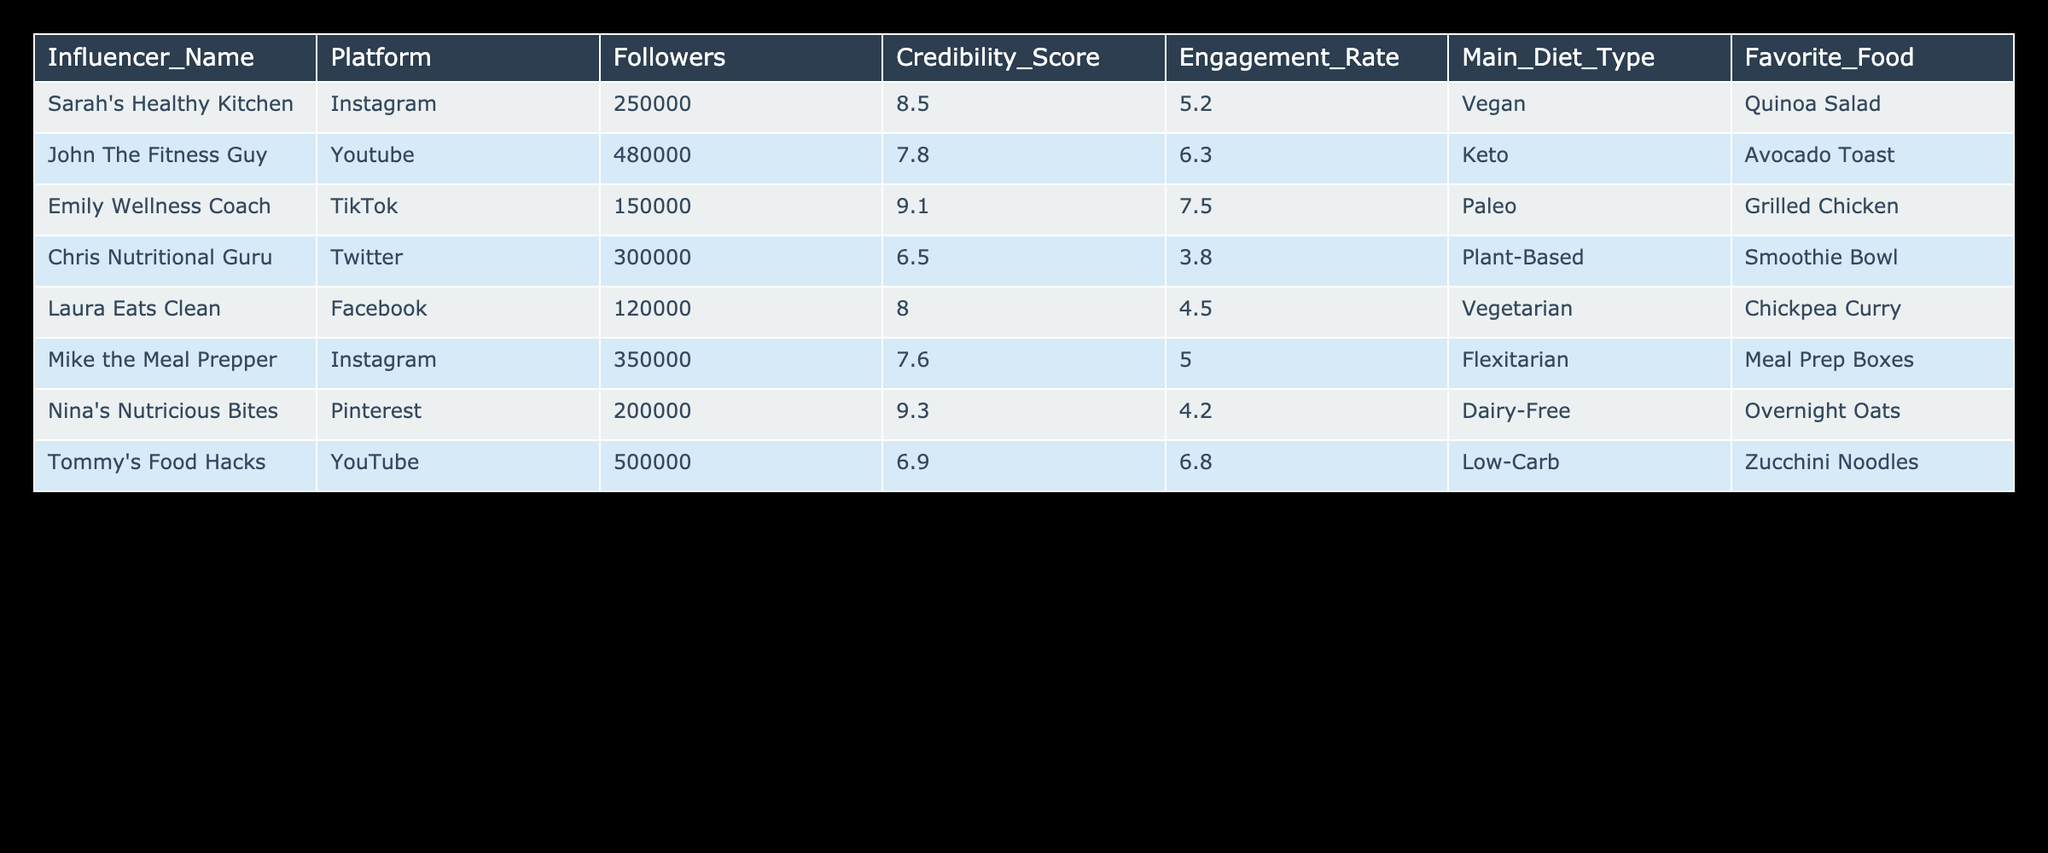What is the Credibility Score of Emily Wellness Coach? Directly refer to the table; the Credibility Score for Emily Wellness Coach is listed as 9.1.
Answer: 9.1 Which influencer has the highest Engagement Rate? Looking through the Engagement Rates in the table, Emily Wellness Coach has an Engagement Rate of 7.5, which is the highest compared to others.
Answer: Emily Wellness Coach Is the Favorite Food of John The Fitness Guy a vegetarian dish? Check John The Fitness Guy’s Favorite Food, which is Avocado Toast. Since it can contain eggs and cheese, it is not strictly vegetarian.
Answer: No What is the average Credibility Score of the influencers whose main diet type is plant-based? Identify the Credibility Scores for influencers with a plant-based diet: Chris Nutritional Guru (6.5) and Nina's Nutricious Bites (9.3). Calculate the average: (6.5 + 9.3) / 2 = 7.9.
Answer: 7.9 How many influencers have more than 200,000 followers? Filter through the Followers column: Sarah's Healthy Kitchen, John The Fitness Guy, Mike the Meal Prepper, and Tommy's Food Hacks have more than 200,000 followers, making a total of 4 influencers.
Answer: 4 Which platform has the influencer with the lowest Engagement Rate? Assess the Engagement Rates: Chris Nutritional Guru has the lowest rate at 3.8 on Twitter.
Answer: Twitter Are there more influencers with a Vegan or Vegetarian main diet type? List the main diet types: Vegan (1), Vegetarian (1), which indicates that they are equal. Thus, both categories have the same number of influencers.
Answer: Equal Which influencer has the largest follower count and what is their Credibility Score? Tommy's Food Hacks has the largest follower count at 500,000, and their Credibility Score is 6.9.
Answer: 500,000 and 6.9 What is the difference in Engagement Rates between the influencer with the highest and lowest score? The highest Engagement Rate is from Emily Wellness Coach (7.5), and the lowest is Chris Nutritional Guru (3.8). Calculate the difference: 7.5 - 3.8 = 3.7.
Answer: 3.7 